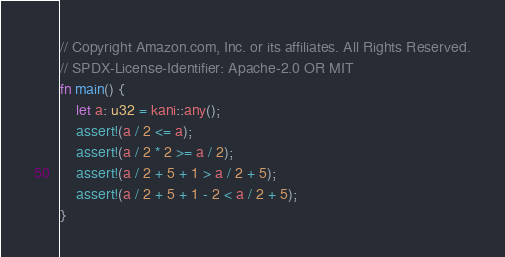Convert code to text. <code><loc_0><loc_0><loc_500><loc_500><_Rust_>// Copyright Amazon.com, Inc. or its affiliates. All Rights Reserved.
// SPDX-License-Identifier: Apache-2.0 OR MIT
fn main() {
    let a: u32 = kani::any();
    assert!(a / 2 <= a);
    assert!(a / 2 * 2 >= a / 2);
    assert!(a / 2 + 5 + 1 > a / 2 + 5);
    assert!(a / 2 + 5 + 1 - 2 < a / 2 + 5);
}
</code> 